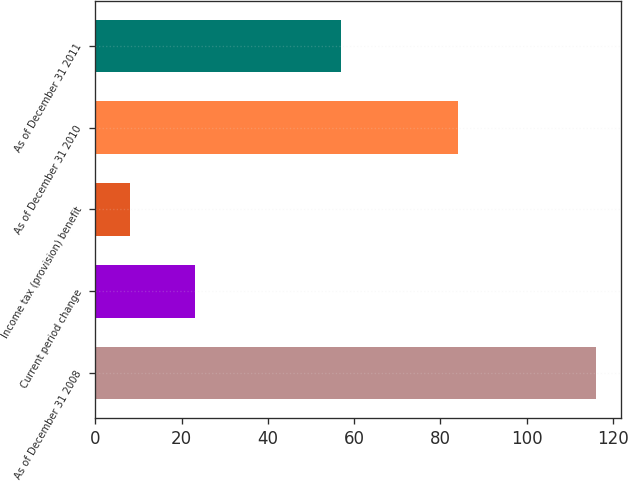Convert chart to OTSL. <chart><loc_0><loc_0><loc_500><loc_500><bar_chart><fcel>As of December 31 2008<fcel>Current period change<fcel>Income tax (provision) benefit<fcel>As of December 31 2010<fcel>As of December 31 2011<nl><fcel>116<fcel>23<fcel>8<fcel>84<fcel>57<nl></chart> 